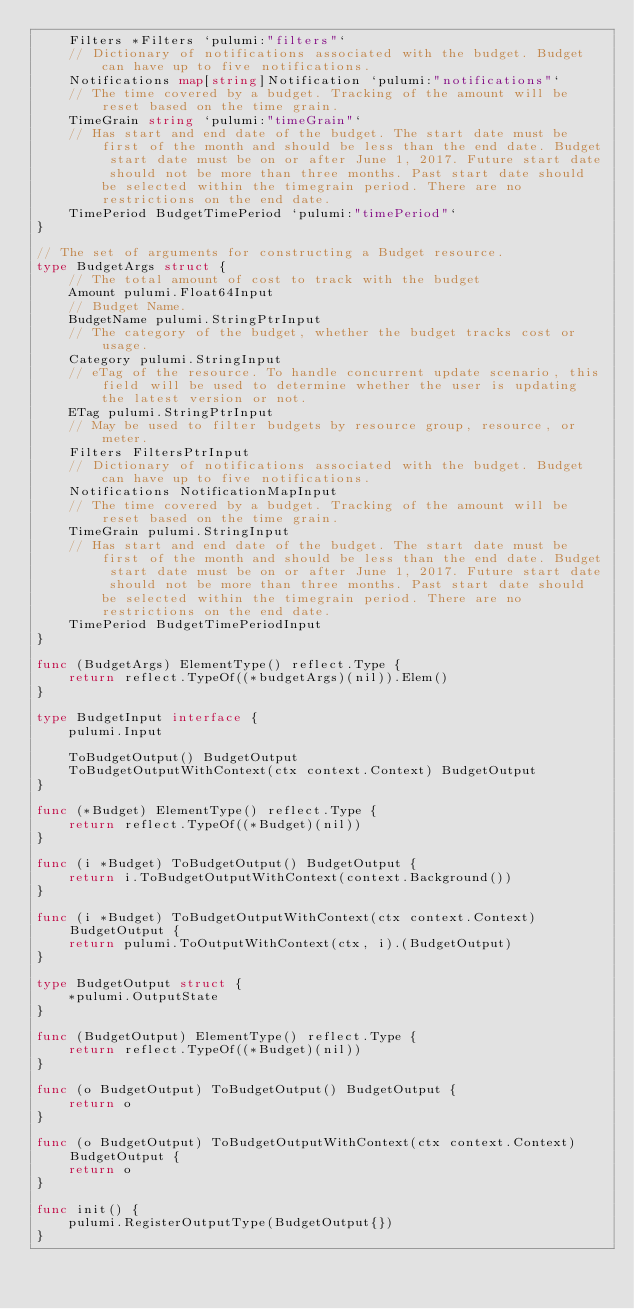Convert code to text. <code><loc_0><loc_0><loc_500><loc_500><_Go_>	Filters *Filters `pulumi:"filters"`
	// Dictionary of notifications associated with the budget. Budget can have up to five notifications.
	Notifications map[string]Notification `pulumi:"notifications"`
	// The time covered by a budget. Tracking of the amount will be reset based on the time grain.
	TimeGrain string `pulumi:"timeGrain"`
	// Has start and end date of the budget. The start date must be first of the month and should be less than the end date. Budget start date must be on or after June 1, 2017. Future start date should not be more than three months. Past start date should  be selected within the timegrain period. There are no restrictions on the end date.
	TimePeriod BudgetTimePeriod `pulumi:"timePeriod"`
}

// The set of arguments for constructing a Budget resource.
type BudgetArgs struct {
	// The total amount of cost to track with the budget
	Amount pulumi.Float64Input
	// Budget Name.
	BudgetName pulumi.StringPtrInput
	// The category of the budget, whether the budget tracks cost or usage.
	Category pulumi.StringInput
	// eTag of the resource. To handle concurrent update scenario, this field will be used to determine whether the user is updating the latest version or not.
	ETag pulumi.StringPtrInput
	// May be used to filter budgets by resource group, resource, or meter.
	Filters FiltersPtrInput
	// Dictionary of notifications associated with the budget. Budget can have up to five notifications.
	Notifications NotificationMapInput
	// The time covered by a budget. Tracking of the amount will be reset based on the time grain.
	TimeGrain pulumi.StringInput
	// Has start and end date of the budget. The start date must be first of the month and should be less than the end date. Budget start date must be on or after June 1, 2017. Future start date should not be more than three months. Past start date should  be selected within the timegrain period. There are no restrictions on the end date.
	TimePeriod BudgetTimePeriodInput
}

func (BudgetArgs) ElementType() reflect.Type {
	return reflect.TypeOf((*budgetArgs)(nil)).Elem()
}

type BudgetInput interface {
	pulumi.Input

	ToBudgetOutput() BudgetOutput
	ToBudgetOutputWithContext(ctx context.Context) BudgetOutput
}

func (*Budget) ElementType() reflect.Type {
	return reflect.TypeOf((*Budget)(nil))
}

func (i *Budget) ToBudgetOutput() BudgetOutput {
	return i.ToBudgetOutputWithContext(context.Background())
}

func (i *Budget) ToBudgetOutputWithContext(ctx context.Context) BudgetOutput {
	return pulumi.ToOutputWithContext(ctx, i).(BudgetOutput)
}

type BudgetOutput struct {
	*pulumi.OutputState
}

func (BudgetOutput) ElementType() reflect.Type {
	return reflect.TypeOf((*Budget)(nil))
}

func (o BudgetOutput) ToBudgetOutput() BudgetOutput {
	return o
}

func (o BudgetOutput) ToBudgetOutputWithContext(ctx context.Context) BudgetOutput {
	return o
}

func init() {
	pulumi.RegisterOutputType(BudgetOutput{})
}
</code> 